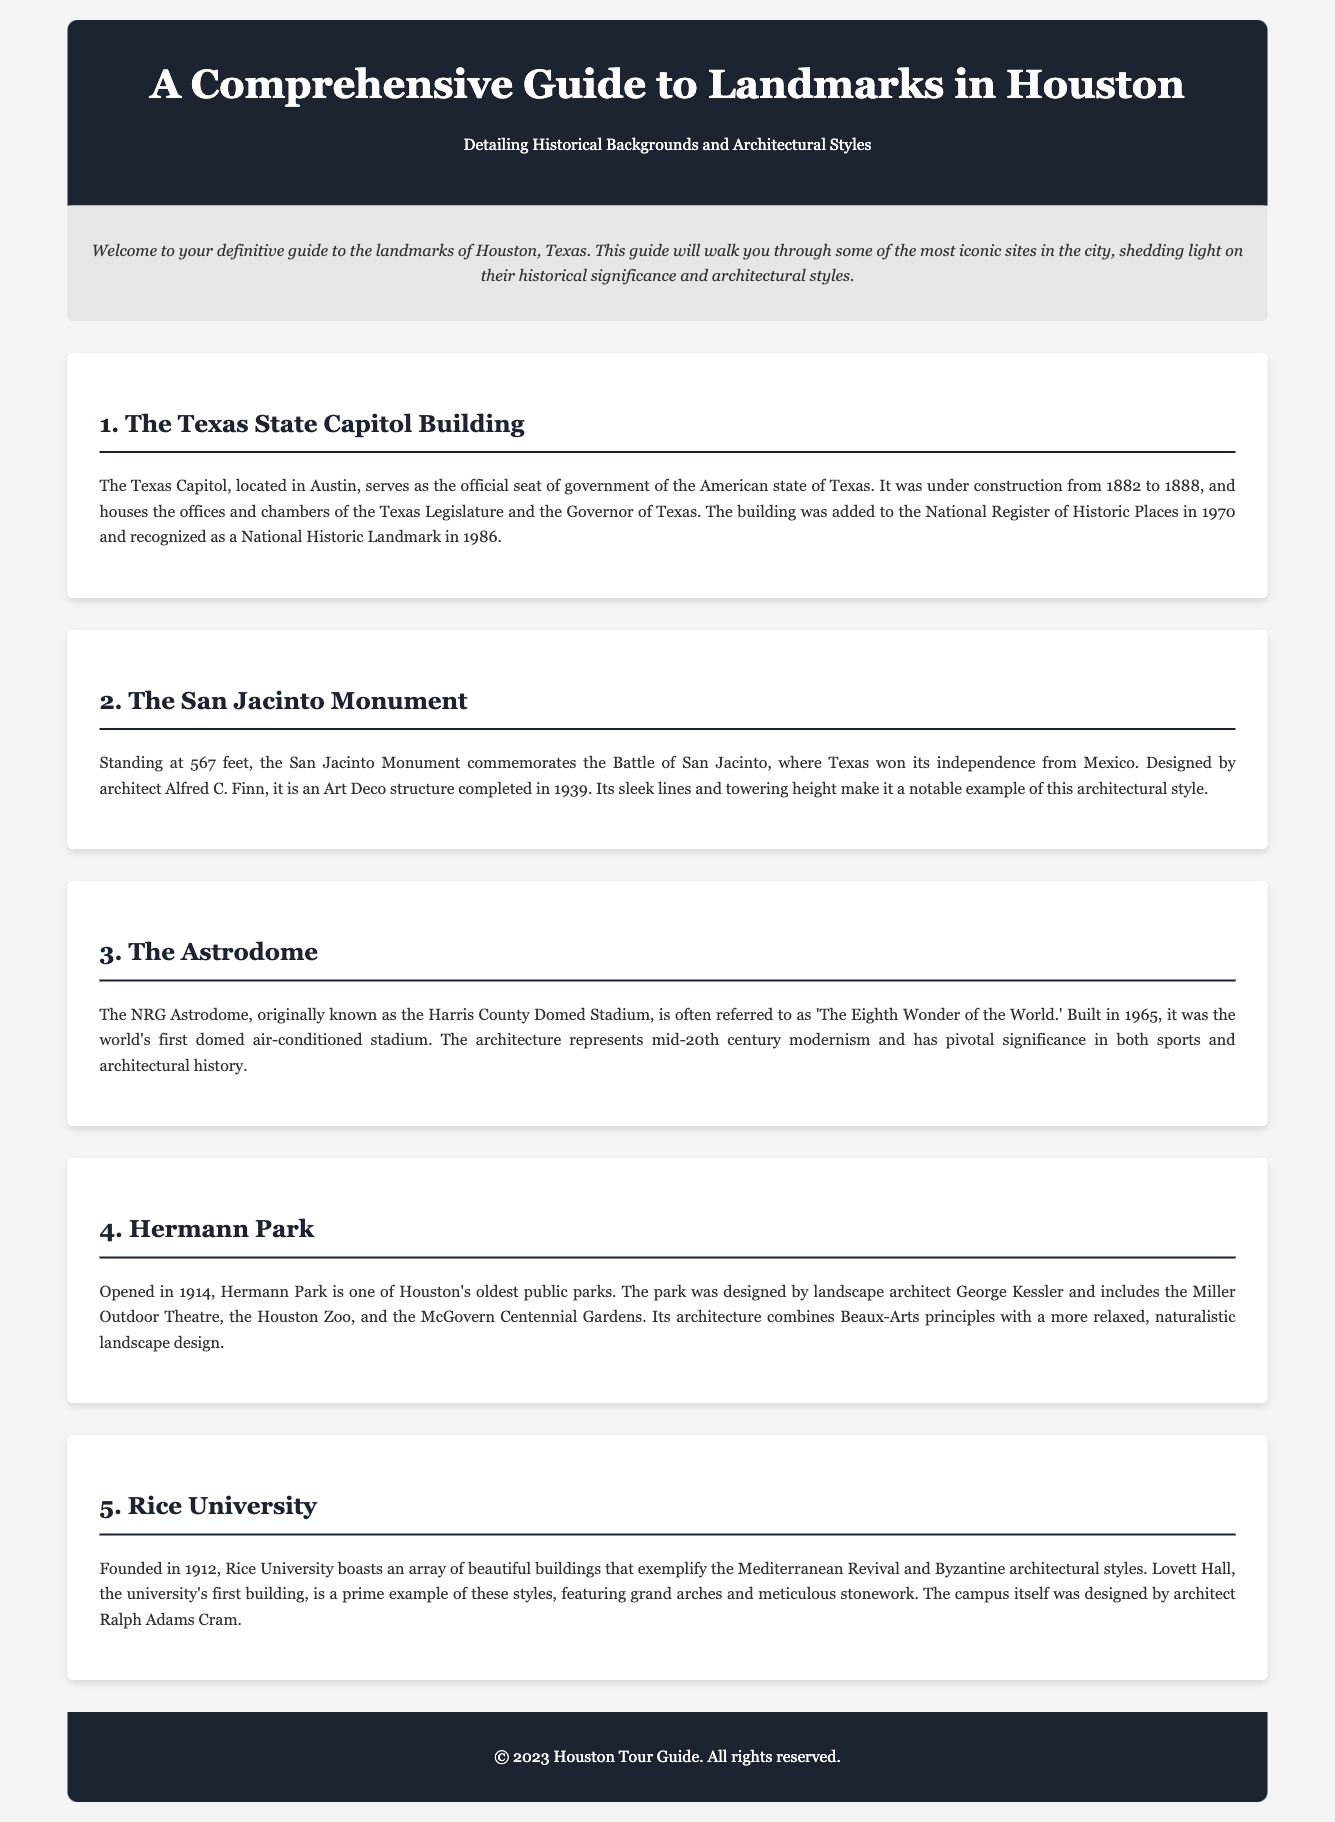What is the title of the guide? The title of the guide, as stated in the header, is "A Comprehensive Guide to Landmarks in Houston."
Answer: A Comprehensive Guide to Landmarks in Houston What year did the Texas Capitol begin construction? The document mentions that the Texas Capitol was under construction from 1882.
Answer: 1882 How tall is the San Jacinto Monument? The text states that the San Jacinto Monument stands at 567 feet.
Answer: 567 feet What architectural style is represented by the Astrodome? The architecture of the Astrodome represents mid-20th century modernism.
Answer: mid-20th century modernism Who designed Hermann Park? The landscape architect who designed Hermann Park, as noted in the document, is George Kessler.
Answer: George Kessler What architectural styles are exemplified by Rice University? The document lists Mediterranean Revival and Byzantine architectural styles as exemplified by Rice University.
Answer: Mediterranean Revival and Byzantine What significant event does the San Jacinto Monument commemorate? The San Jacinto Monument commemorates the Battle of San Jacinto.
Answer: Battle of San Jacinto What is the established year of Rice University? The document states that Rice University was founded in 1912.
Answer: 1912 How many landmarks are detailed in the guide? The guide details five landmarks throughout the document.
Answer: Five 